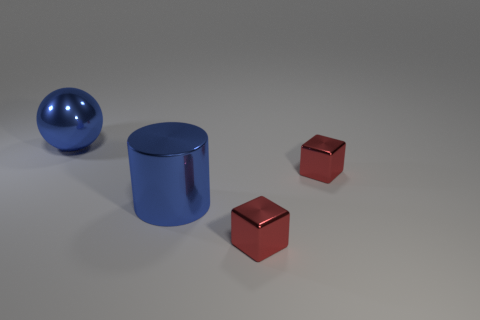Add 2 shiny objects. How many objects exist? 6 Subtract all cylinders. How many objects are left? 3 Subtract 0 blue blocks. How many objects are left? 4 Subtract all large metallic objects. Subtract all blue spheres. How many objects are left? 1 Add 2 red metallic blocks. How many red metallic blocks are left? 4 Add 1 blue things. How many blue things exist? 3 